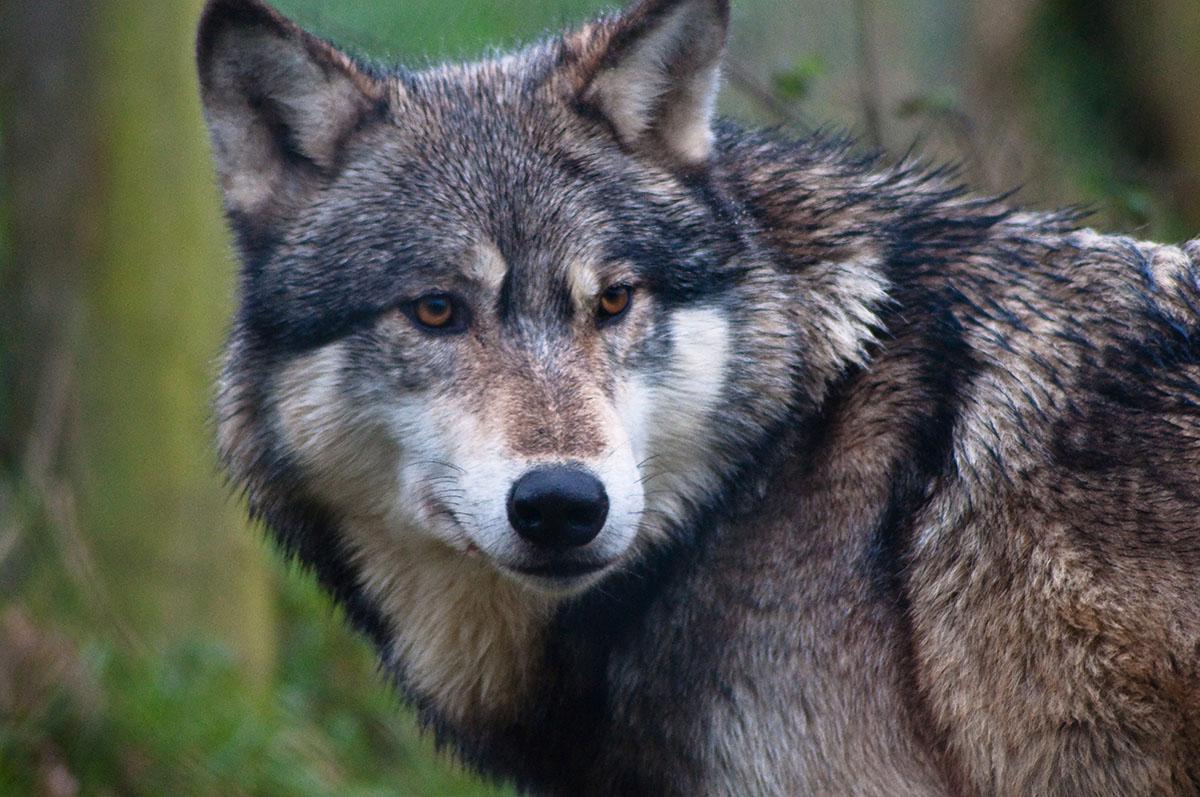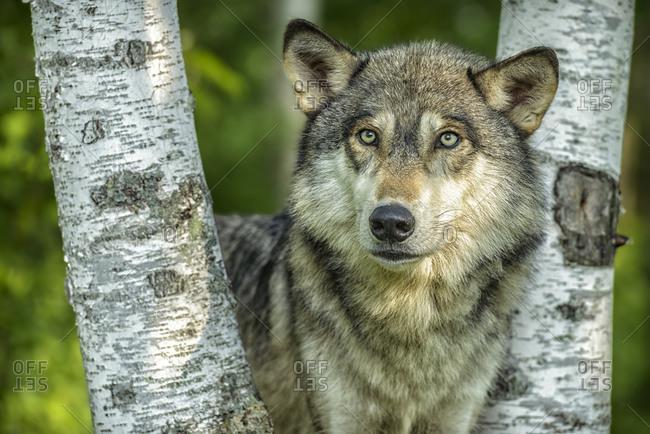The first image is the image on the left, the second image is the image on the right. Assess this claim about the two images: "There are exactly four wolves in total.". Correct or not? Answer yes or no. No. The first image is the image on the left, the second image is the image on the right. For the images shown, is this caption "The left image shows exactly two wolves, at least one with its mouth open and at least one with its eyes shut." true? Answer yes or no. No. 